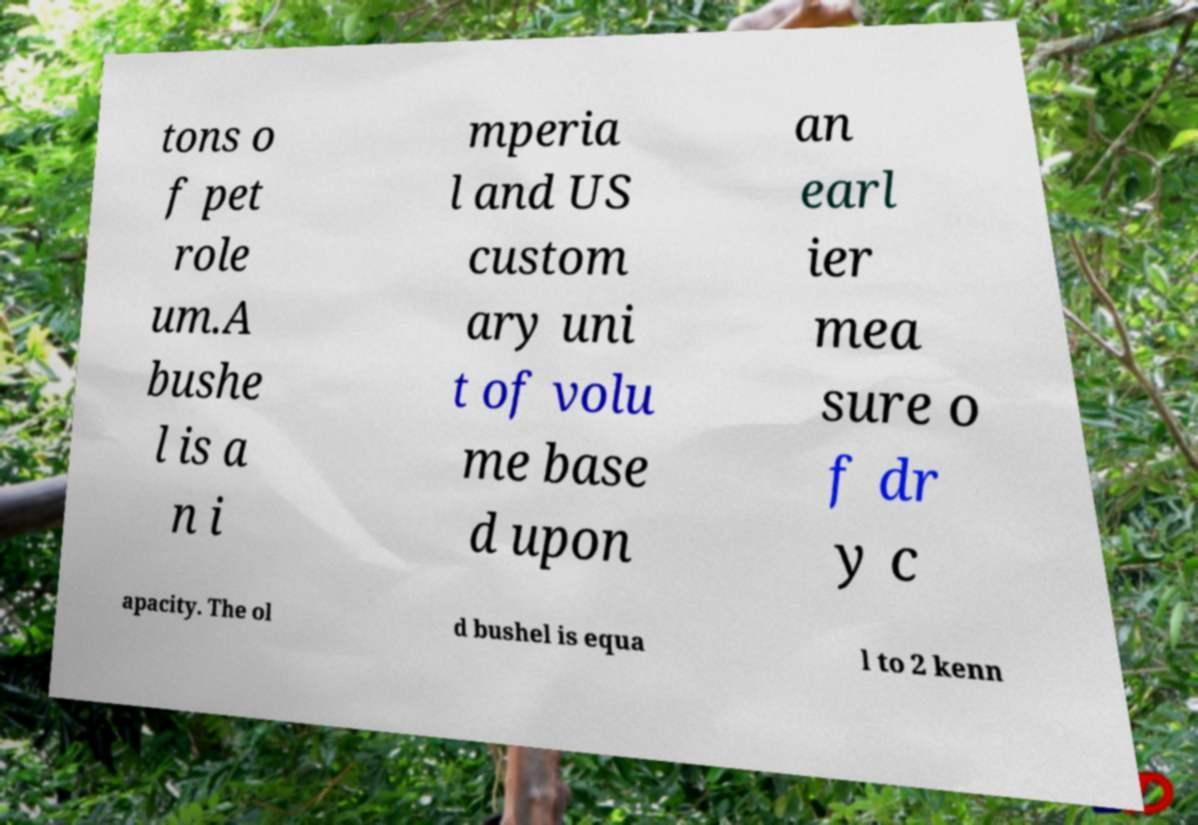There's text embedded in this image that I need extracted. Can you transcribe it verbatim? tons o f pet role um.A bushe l is a n i mperia l and US custom ary uni t of volu me base d upon an earl ier mea sure o f dr y c apacity. The ol d bushel is equa l to 2 kenn 